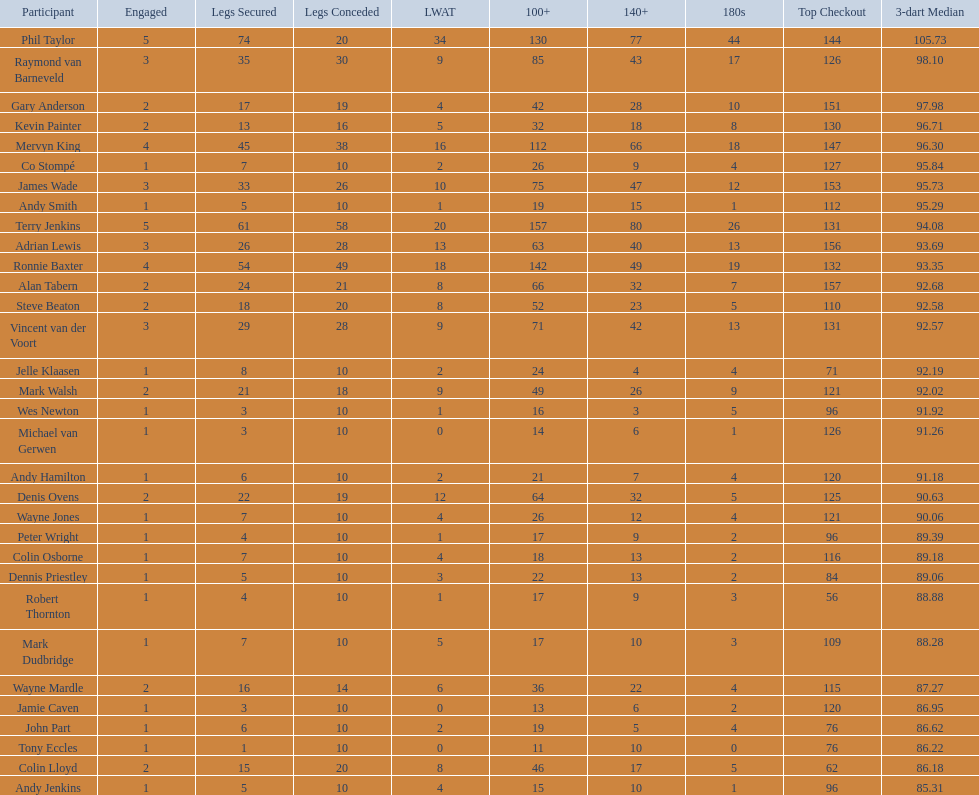What were the total number of legs won by ronnie baxter? 54. 